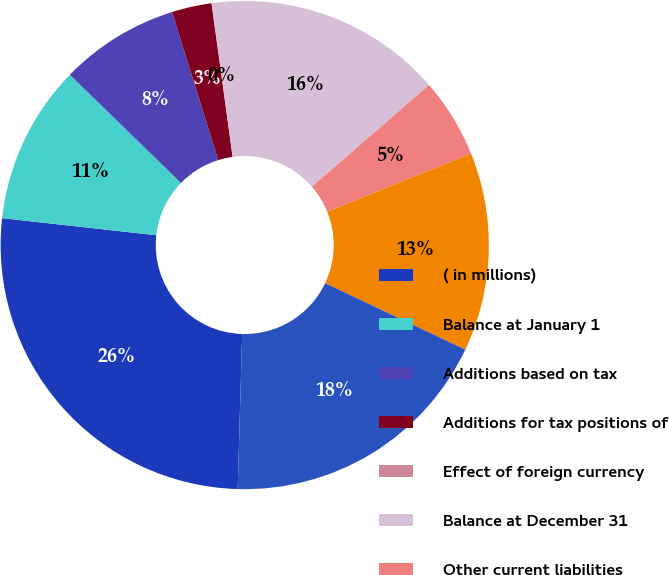Convert chart to OTSL. <chart><loc_0><loc_0><loc_500><loc_500><pie_chart><fcel>( in millions)<fcel>Balance at January 1<fcel>Additions based on tax<fcel>Additions for tax positions of<fcel>Effect of foreign currency<fcel>Balance at December 31<fcel>Other current liabilities<fcel>Deferred taxes and other<fcel>Total<nl><fcel>26.3%<fcel>10.53%<fcel>7.9%<fcel>2.64%<fcel>0.01%<fcel>15.78%<fcel>5.27%<fcel>13.16%<fcel>18.41%<nl></chart> 